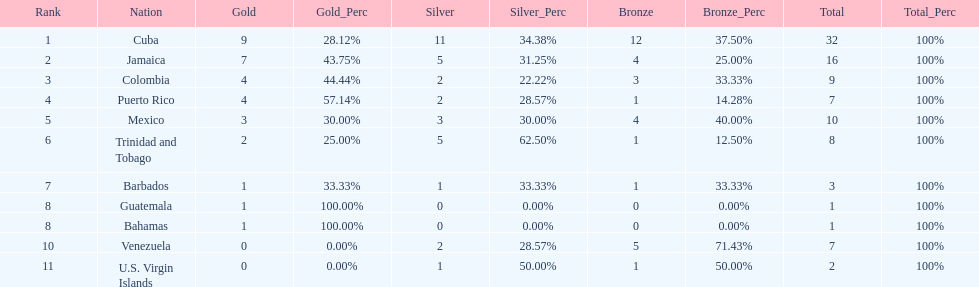Nations that had 10 or more medals each Cuba, Jamaica, Mexico. 